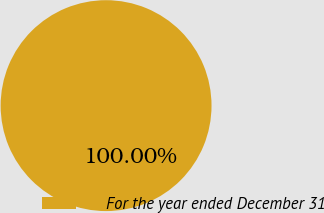Convert chart to OTSL. <chart><loc_0><loc_0><loc_500><loc_500><pie_chart><fcel>For the year ended December 31<nl><fcel>100.0%<nl></chart> 